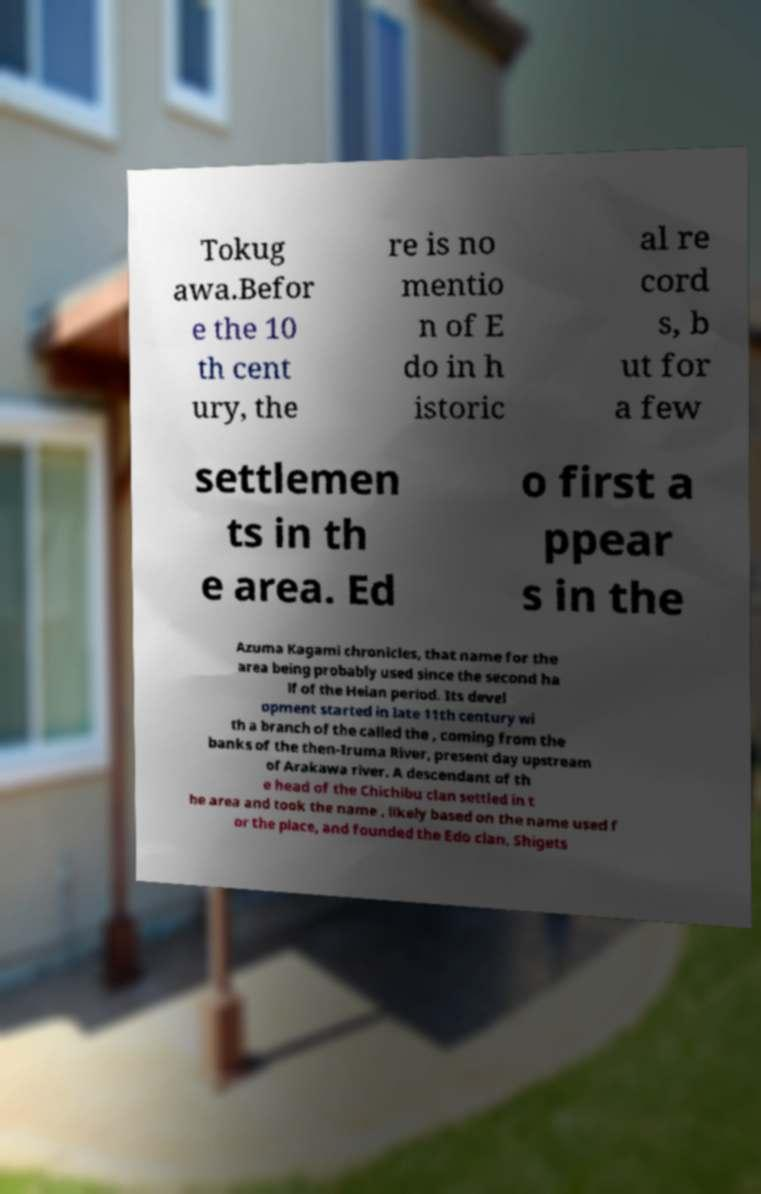Please read and relay the text visible in this image. What does it say? Tokug awa.Befor e the 10 th cent ury, the re is no mentio n of E do in h istoric al re cord s, b ut for a few settlemen ts in th e area. Ed o first a ppear s in the Azuma Kagami chronicles, that name for the area being probably used since the second ha lf of the Heian period. Its devel opment started in late 11th century wi th a branch of the called the , coming from the banks of the then-Iruma River, present day upstream of Arakawa river. A descendant of th e head of the Chichibu clan settled in t he area and took the name , likely based on the name used f or the place, and founded the Edo clan. Shigets 